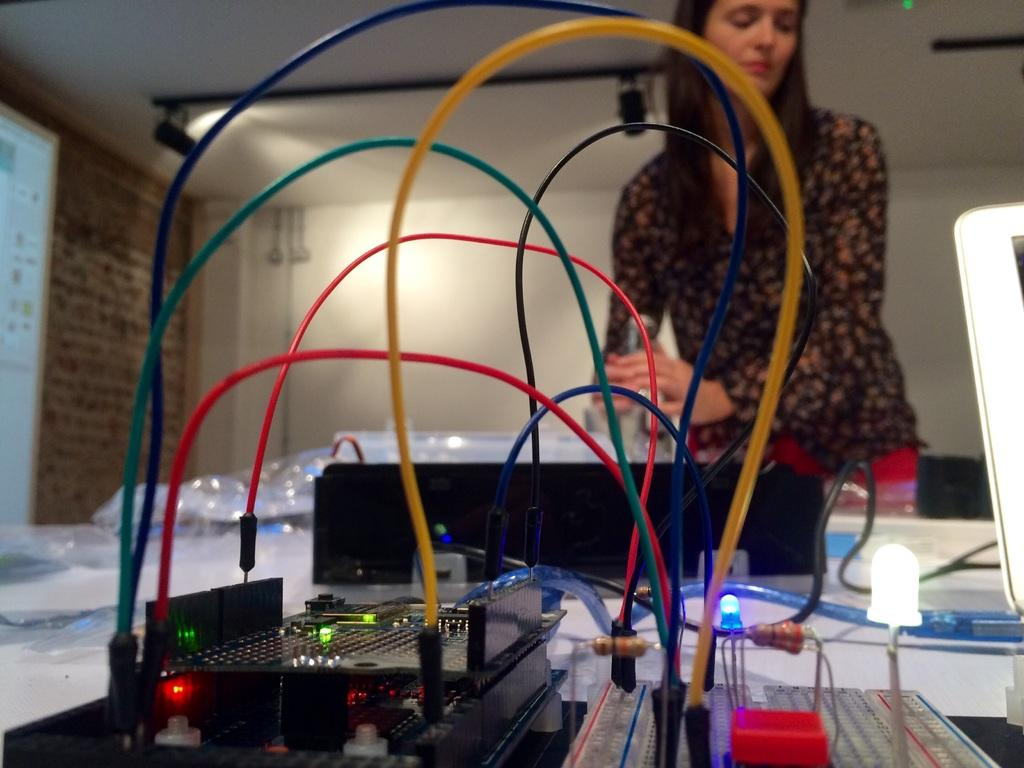Who or what is present in the image? There is a person in the image. What can be observed about the person's attire? The person is wearing clothes. What type of object is located at the bottom of the image? There is an electrical equipment at the bottom of the image. Where is the screen positioned in the image? The screen is on the left side of the image. What type of drum can be heard playing in the background of the image? There is no drum or sound present in the image; it is a still image. 